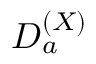Convert formula to latex. <formula><loc_0><loc_0><loc_500><loc_500>D _ { a } ^ { ( X ) }</formula> 